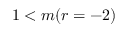Convert formula to latex. <formula><loc_0><loc_0><loc_500><loc_500>1 < m ( r = - 2 )</formula> 